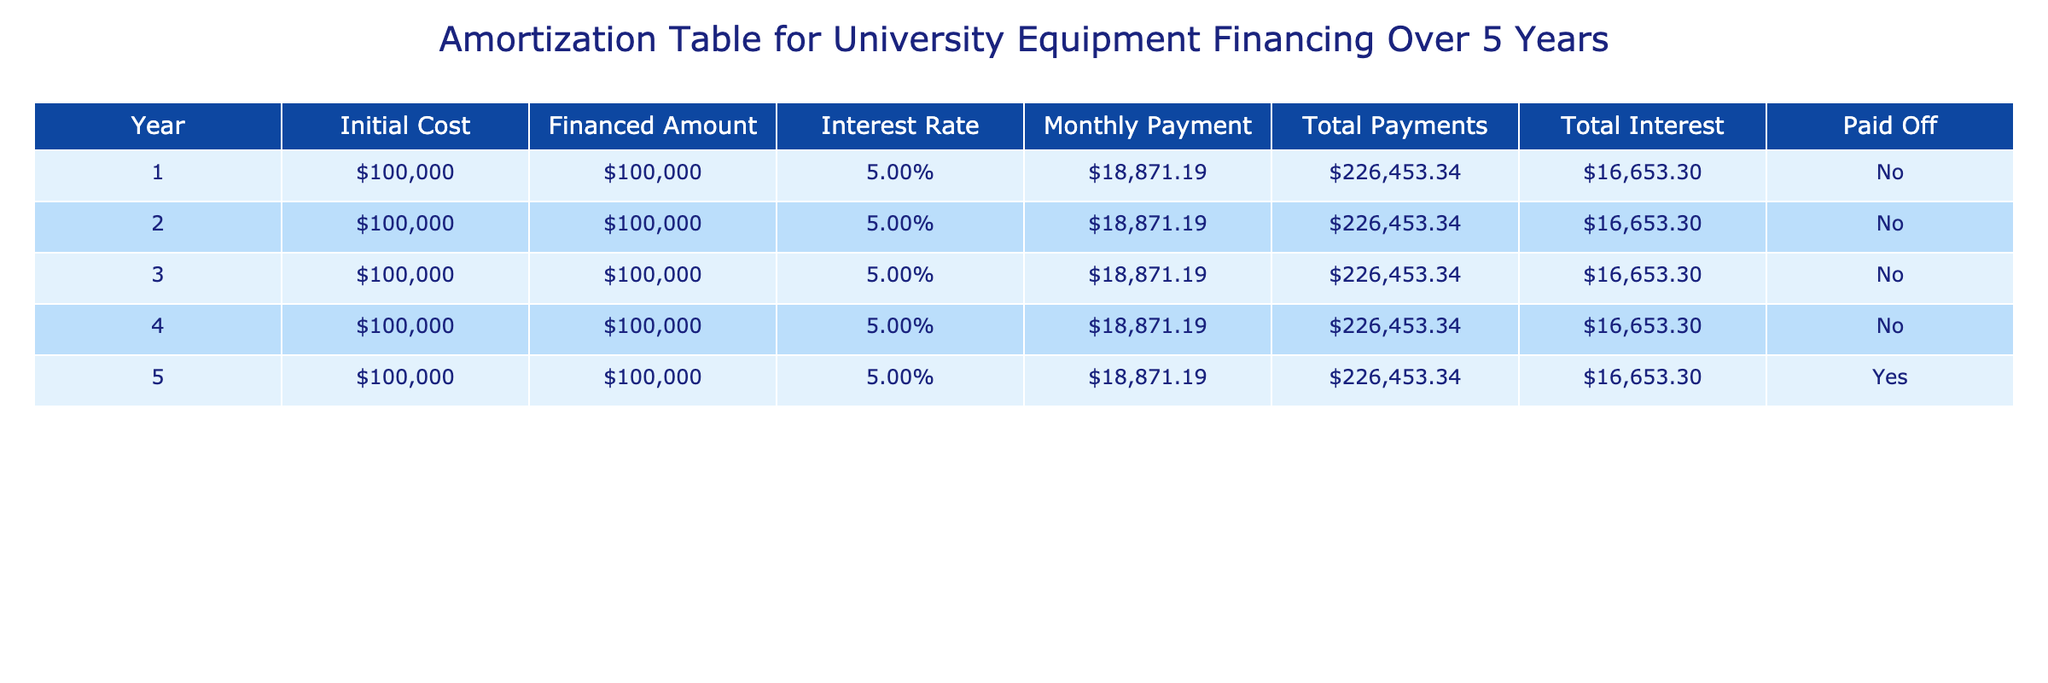What is the total amount of interest paid over the five years? The total interest paid can be found in the "Total Interest" column for any year since it is constant at $16,653.30. Since this amount applies for each of the five years, we can simply state that the total interest paid over the five years is this constant amount.
Answer: $16,653.30 How much will the university pay in total for the financed amount over the five years? The total amount paid for the financed amount can be found in the "Total Payments" column for any year. It shows a total of $226,453.34, which includes both the financed amount and interest.
Answer: $226,453.34 Is the financed amount equal to the initial cost of the equipment? By looking at the "Financed Amount" and "Initial Cost" columns, both show a value of $100,000. This indicates that the financed amount is equal to the initial cost of the equipment.
Answer: Yes What is the monthly payment for the financing? The "Monthly Payment" column provides the monthly payment amount. It shows $18,871.19 for each year, confirming this is the amount paid monthly over the financing period.
Answer: $18,871.19 In which year was the equipment paid off? The "Paid Off" column indicates whether the amount was paid off or not. It states "Yes" in Year 5, which signifies that the equipment was paid off in that year.
Answer: Year 5 How much total was paid in interest by the end of year 3? To calculate the total interest by the end of year 3, we find the total interest for the first three years. Each year shows $16,653.30, so we can sum that over three years: $16,653.30 x 3 = $49,959.90.
Answer: $49,959.90 What is the average monthly payment across the five-year period? The monthly payment is constant at $18,871.19 over the five years. Average monthly payment is calculated by dividing the total payments for the month by the number of months in five years: ($18,871.19 * 60)/60 = $18,871.19.
Answer: $18,871.19 What is the difference between the total payments and the financed amount? The "Total Payments" column shows $226,453.34 and the "Financed Amount" shows $100,000. The difference is calculated as $226,453.34 - $100,000 = $126,453.34, which represents the total interest paid.
Answer: $126,453.34 What percentage of the total payments is made up of interest? To find the percentage of total payments that is interest, we can divide total interest by total payments: ($16,653.30 / $226,453.34) x 100, which calculates to approximately 7.36%.
Answer: 7.36% 